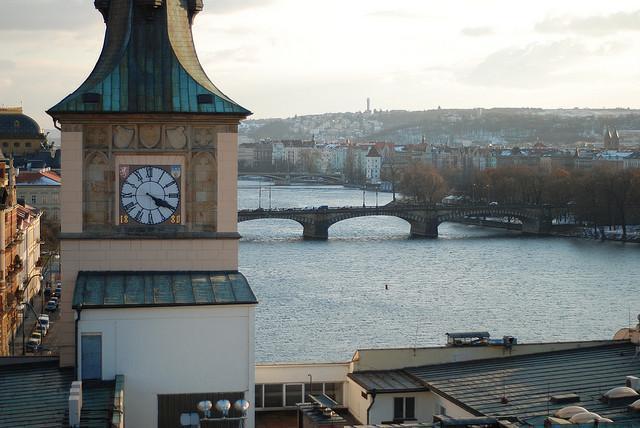How many chairs do you see?
Give a very brief answer. 0. 